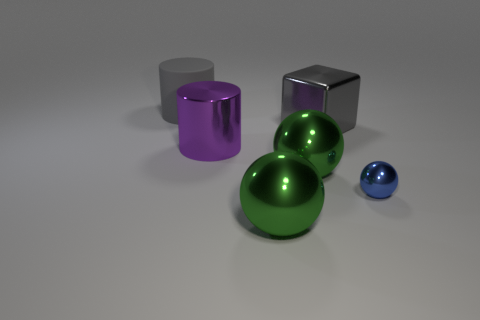There is a metal cylinder that is the same size as the rubber cylinder; what color is it?
Offer a very short reply. Purple. Do the small thing and the large purple object have the same material?
Your answer should be compact. Yes. There is a large green object in front of the large green object behind the tiny blue object; what is it made of?
Your response must be concise. Metal. Is the number of blue spheres in front of the blue metallic ball greater than the number of green metallic cubes?
Keep it short and to the point. No. What number of other objects are the same size as the blue ball?
Offer a very short reply. 0. Do the rubber thing and the tiny metal object have the same color?
Give a very brief answer. No. The ball on the right side of the large sphere on the right side of the large green shiny ball that is in front of the tiny blue ball is what color?
Provide a short and direct response. Blue. What number of large objects are behind the big metallic cube that is on the right side of the object that is to the left of the purple cylinder?
Give a very brief answer. 1. Is there any other thing that is the same color as the big shiny cylinder?
Your answer should be very brief. No. There is a ball that is in front of the blue ball; does it have the same size as the blue metallic object?
Make the answer very short. No. 